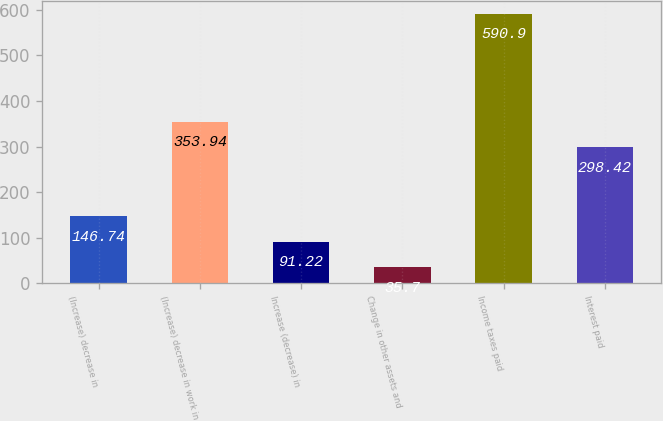<chart> <loc_0><loc_0><loc_500><loc_500><bar_chart><fcel>(Increase) decrease in<fcel>(Increase) decrease in work in<fcel>Increase (decrease) in<fcel>Change in other assets and<fcel>Income taxes paid<fcel>Interest paid<nl><fcel>146.74<fcel>353.94<fcel>91.22<fcel>35.7<fcel>590.9<fcel>298.42<nl></chart> 